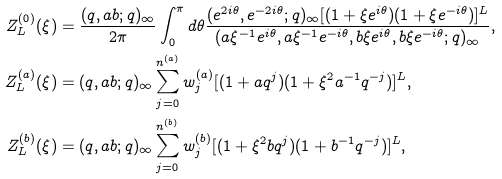<formula> <loc_0><loc_0><loc_500><loc_500>Z _ { L } ^ { ( 0 ) } ( \xi ) & = \frac { ( q , a b ; q ) _ { \infty } } { 2 \pi } \int _ { 0 } ^ { \pi } d \theta \frac { ( e ^ { 2 i \theta } , e ^ { - 2 i \theta } ; q ) _ { \infty } [ ( 1 + \xi e ^ { i \theta } ) ( 1 + \xi e ^ { - i \theta } ) ] ^ { L } } { ( a \xi ^ { - 1 } e ^ { i \theta } , a \xi ^ { - 1 } e ^ { - i \theta } , b \xi e ^ { i \theta } , b \xi e ^ { - i \theta } ; q ) _ { \infty } } , \\ Z _ { L } ^ { ( a ) } ( \xi ) & = ( q , a b ; q ) _ { \infty } \sum _ { j = 0 } ^ { n ^ { ( a ) } } w _ { j } ^ { ( a ) } [ ( 1 + a q ^ { j } ) ( 1 + \xi ^ { 2 } a ^ { - 1 } q ^ { - j } ) ] ^ { L } , \\ Z _ { L } ^ { ( b ) } ( \xi ) & = ( q , a b ; q ) _ { \infty } \sum _ { j = 0 } ^ { n ^ { ( b ) } } w _ { j } ^ { ( b ) } [ ( 1 + \xi ^ { 2 } b q ^ { j } ) ( 1 + b ^ { - 1 } q ^ { - j } ) ] ^ { L } ,</formula> 